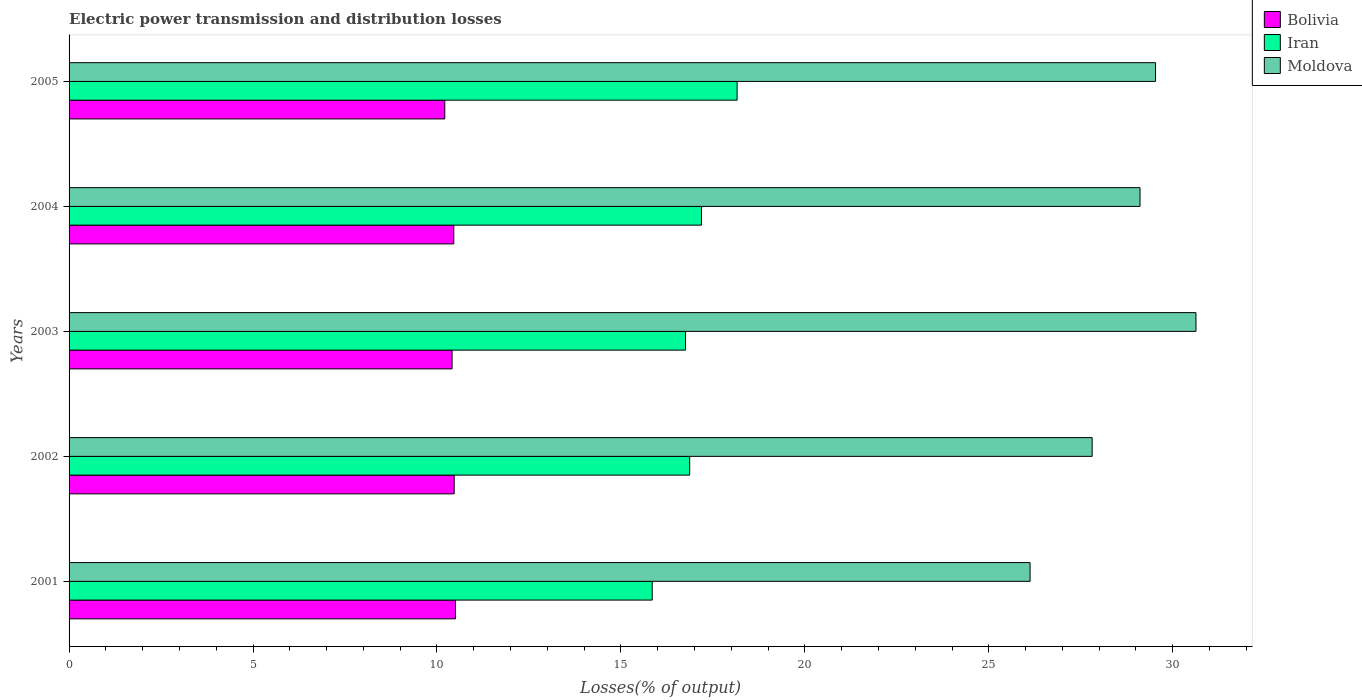How many different coloured bars are there?
Offer a very short reply. 3. Are the number of bars on each tick of the Y-axis equal?
Provide a short and direct response. Yes. How many bars are there on the 1st tick from the top?
Offer a terse response. 3. What is the electric power transmission and distribution losses in Iran in 2002?
Give a very brief answer. 16.87. Across all years, what is the maximum electric power transmission and distribution losses in Moldova?
Your response must be concise. 30.63. Across all years, what is the minimum electric power transmission and distribution losses in Bolivia?
Your answer should be very brief. 10.21. In which year was the electric power transmission and distribution losses in Iran maximum?
Offer a terse response. 2005. What is the total electric power transmission and distribution losses in Iran in the graph?
Provide a succinct answer. 84.82. What is the difference between the electric power transmission and distribution losses in Iran in 2001 and that in 2002?
Provide a succinct answer. -1.02. What is the difference between the electric power transmission and distribution losses in Moldova in 2005 and the electric power transmission and distribution losses in Bolivia in 2001?
Make the answer very short. 19.03. What is the average electric power transmission and distribution losses in Moldova per year?
Offer a terse response. 28.64. In the year 2005, what is the difference between the electric power transmission and distribution losses in Moldova and electric power transmission and distribution losses in Iran?
Make the answer very short. 11.37. What is the ratio of the electric power transmission and distribution losses in Iran in 2001 to that in 2004?
Give a very brief answer. 0.92. Is the electric power transmission and distribution losses in Iran in 2003 less than that in 2005?
Offer a terse response. Yes. What is the difference between the highest and the second highest electric power transmission and distribution losses in Iran?
Offer a terse response. 0.97. What is the difference between the highest and the lowest electric power transmission and distribution losses in Bolivia?
Provide a succinct answer. 0.29. In how many years, is the electric power transmission and distribution losses in Iran greater than the average electric power transmission and distribution losses in Iran taken over all years?
Your response must be concise. 2. What does the 1st bar from the top in 2003 represents?
Provide a short and direct response. Moldova. What does the 2nd bar from the bottom in 2001 represents?
Provide a short and direct response. Iran. Is it the case that in every year, the sum of the electric power transmission and distribution losses in Moldova and electric power transmission and distribution losses in Bolivia is greater than the electric power transmission and distribution losses in Iran?
Provide a succinct answer. Yes. How many bars are there?
Provide a succinct answer. 15. How many years are there in the graph?
Provide a succinct answer. 5. Are the values on the major ticks of X-axis written in scientific E-notation?
Your answer should be compact. No. How many legend labels are there?
Give a very brief answer. 3. What is the title of the graph?
Keep it short and to the point. Electric power transmission and distribution losses. Does "Guyana" appear as one of the legend labels in the graph?
Offer a very short reply. No. What is the label or title of the X-axis?
Give a very brief answer. Losses(% of output). What is the label or title of the Y-axis?
Keep it short and to the point. Years. What is the Losses(% of output) in Bolivia in 2001?
Provide a succinct answer. 10.5. What is the Losses(% of output) of Iran in 2001?
Make the answer very short. 15.85. What is the Losses(% of output) of Moldova in 2001?
Your response must be concise. 26.12. What is the Losses(% of output) of Bolivia in 2002?
Offer a terse response. 10.47. What is the Losses(% of output) of Iran in 2002?
Your answer should be compact. 16.87. What is the Losses(% of output) in Moldova in 2002?
Your answer should be very brief. 27.81. What is the Losses(% of output) of Bolivia in 2003?
Ensure brevity in your answer.  10.41. What is the Losses(% of output) in Iran in 2003?
Offer a terse response. 16.76. What is the Losses(% of output) of Moldova in 2003?
Your answer should be very brief. 30.63. What is the Losses(% of output) in Bolivia in 2004?
Offer a terse response. 10.46. What is the Losses(% of output) in Iran in 2004?
Your response must be concise. 17.19. What is the Losses(% of output) in Moldova in 2004?
Offer a very short reply. 29.11. What is the Losses(% of output) of Bolivia in 2005?
Make the answer very short. 10.21. What is the Losses(% of output) in Iran in 2005?
Offer a very short reply. 18.16. What is the Losses(% of output) in Moldova in 2005?
Your answer should be compact. 29.53. Across all years, what is the maximum Losses(% of output) in Bolivia?
Provide a short and direct response. 10.5. Across all years, what is the maximum Losses(% of output) of Iran?
Ensure brevity in your answer.  18.16. Across all years, what is the maximum Losses(% of output) of Moldova?
Your response must be concise. 30.63. Across all years, what is the minimum Losses(% of output) of Bolivia?
Your response must be concise. 10.21. Across all years, what is the minimum Losses(% of output) in Iran?
Provide a succinct answer. 15.85. Across all years, what is the minimum Losses(% of output) in Moldova?
Give a very brief answer. 26.12. What is the total Losses(% of output) in Bolivia in the graph?
Offer a very short reply. 52.05. What is the total Losses(% of output) in Iran in the graph?
Provide a short and direct response. 84.82. What is the total Losses(% of output) in Moldova in the graph?
Ensure brevity in your answer.  143.21. What is the difference between the Losses(% of output) of Bolivia in 2001 and that in 2002?
Provide a succinct answer. 0.03. What is the difference between the Losses(% of output) in Iran in 2001 and that in 2002?
Your answer should be very brief. -1.02. What is the difference between the Losses(% of output) of Moldova in 2001 and that in 2002?
Your response must be concise. -1.69. What is the difference between the Losses(% of output) in Bolivia in 2001 and that in 2003?
Give a very brief answer. 0.09. What is the difference between the Losses(% of output) in Iran in 2001 and that in 2003?
Your response must be concise. -0.91. What is the difference between the Losses(% of output) in Moldova in 2001 and that in 2003?
Provide a succinct answer. -4.51. What is the difference between the Losses(% of output) in Bolivia in 2001 and that in 2004?
Your answer should be compact. 0.04. What is the difference between the Losses(% of output) in Iran in 2001 and that in 2004?
Offer a terse response. -1.34. What is the difference between the Losses(% of output) in Moldova in 2001 and that in 2004?
Provide a short and direct response. -2.99. What is the difference between the Losses(% of output) of Bolivia in 2001 and that in 2005?
Your response must be concise. 0.29. What is the difference between the Losses(% of output) of Iran in 2001 and that in 2005?
Give a very brief answer. -2.31. What is the difference between the Losses(% of output) in Moldova in 2001 and that in 2005?
Your answer should be compact. -3.41. What is the difference between the Losses(% of output) of Bolivia in 2002 and that in 2003?
Give a very brief answer. 0.06. What is the difference between the Losses(% of output) of Iran in 2002 and that in 2003?
Keep it short and to the point. 0.11. What is the difference between the Losses(% of output) in Moldova in 2002 and that in 2003?
Offer a very short reply. -2.82. What is the difference between the Losses(% of output) of Bolivia in 2002 and that in 2004?
Provide a succinct answer. 0.01. What is the difference between the Losses(% of output) in Iran in 2002 and that in 2004?
Your answer should be very brief. -0.32. What is the difference between the Losses(% of output) of Moldova in 2002 and that in 2004?
Keep it short and to the point. -1.3. What is the difference between the Losses(% of output) in Bolivia in 2002 and that in 2005?
Ensure brevity in your answer.  0.26. What is the difference between the Losses(% of output) in Iran in 2002 and that in 2005?
Your answer should be very brief. -1.29. What is the difference between the Losses(% of output) in Moldova in 2002 and that in 2005?
Give a very brief answer. -1.72. What is the difference between the Losses(% of output) of Bolivia in 2003 and that in 2004?
Provide a succinct answer. -0.05. What is the difference between the Losses(% of output) of Iran in 2003 and that in 2004?
Keep it short and to the point. -0.43. What is the difference between the Losses(% of output) in Moldova in 2003 and that in 2004?
Your answer should be very brief. 1.52. What is the difference between the Losses(% of output) in Bolivia in 2003 and that in 2005?
Give a very brief answer. 0.2. What is the difference between the Losses(% of output) in Iran in 2003 and that in 2005?
Provide a short and direct response. -1.4. What is the difference between the Losses(% of output) of Moldova in 2003 and that in 2005?
Give a very brief answer. 1.1. What is the difference between the Losses(% of output) in Bolivia in 2004 and that in 2005?
Provide a succinct answer. 0.25. What is the difference between the Losses(% of output) in Iran in 2004 and that in 2005?
Keep it short and to the point. -0.97. What is the difference between the Losses(% of output) of Moldova in 2004 and that in 2005?
Provide a succinct answer. -0.42. What is the difference between the Losses(% of output) in Bolivia in 2001 and the Losses(% of output) in Iran in 2002?
Provide a succinct answer. -6.37. What is the difference between the Losses(% of output) in Bolivia in 2001 and the Losses(% of output) in Moldova in 2002?
Provide a succinct answer. -17.31. What is the difference between the Losses(% of output) in Iran in 2001 and the Losses(% of output) in Moldova in 2002?
Your response must be concise. -11.96. What is the difference between the Losses(% of output) in Bolivia in 2001 and the Losses(% of output) in Iran in 2003?
Offer a very short reply. -6.25. What is the difference between the Losses(% of output) in Bolivia in 2001 and the Losses(% of output) in Moldova in 2003?
Give a very brief answer. -20.13. What is the difference between the Losses(% of output) of Iran in 2001 and the Losses(% of output) of Moldova in 2003?
Offer a very short reply. -14.78. What is the difference between the Losses(% of output) in Bolivia in 2001 and the Losses(% of output) in Iran in 2004?
Offer a terse response. -6.69. What is the difference between the Losses(% of output) in Bolivia in 2001 and the Losses(% of output) in Moldova in 2004?
Make the answer very short. -18.61. What is the difference between the Losses(% of output) of Iran in 2001 and the Losses(% of output) of Moldova in 2004?
Keep it short and to the point. -13.26. What is the difference between the Losses(% of output) in Bolivia in 2001 and the Losses(% of output) in Iran in 2005?
Your answer should be compact. -7.66. What is the difference between the Losses(% of output) in Bolivia in 2001 and the Losses(% of output) in Moldova in 2005?
Ensure brevity in your answer.  -19.03. What is the difference between the Losses(% of output) of Iran in 2001 and the Losses(% of output) of Moldova in 2005?
Your answer should be very brief. -13.68. What is the difference between the Losses(% of output) of Bolivia in 2002 and the Losses(% of output) of Iran in 2003?
Provide a short and direct response. -6.29. What is the difference between the Losses(% of output) of Bolivia in 2002 and the Losses(% of output) of Moldova in 2003?
Your response must be concise. -20.16. What is the difference between the Losses(% of output) in Iran in 2002 and the Losses(% of output) in Moldova in 2003?
Ensure brevity in your answer.  -13.76. What is the difference between the Losses(% of output) in Bolivia in 2002 and the Losses(% of output) in Iran in 2004?
Offer a very short reply. -6.72. What is the difference between the Losses(% of output) of Bolivia in 2002 and the Losses(% of output) of Moldova in 2004?
Offer a terse response. -18.64. What is the difference between the Losses(% of output) of Iran in 2002 and the Losses(% of output) of Moldova in 2004?
Ensure brevity in your answer.  -12.24. What is the difference between the Losses(% of output) of Bolivia in 2002 and the Losses(% of output) of Iran in 2005?
Your answer should be very brief. -7.69. What is the difference between the Losses(% of output) of Bolivia in 2002 and the Losses(% of output) of Moldova in 2005?
Keep it short and to the point. -19.06. What is the difference between the Losses(% of output) of Iran in 2002 and the Losses(% of output) of Moldova in 2005?
Keep it short and to the point. -12.66. What is the difference between the Losses(% of output) in Bolivia in 2003 and the Losses(% of output) in Iran in 2004?
Provide a succinct answer. -6.78. What is the difference between the Losses(% of output) of Bolivia in 2003 and the Losses(% of output) of Moldova in 2004?
Your response must be concise. -18.7. What is the difference between the Losses(% of output) in Iran in 2003 and the Losses(% of output) in Moldova in 2004?
Give a very brief answer. -12.35. What is the difference between the Losses(% of output) in Bolivia in 2003 and the Losses(% of output) in Iran in 2005?
Your response must be concise. -7.75. What is the difference between the Losses(% of output) of Bolivia in 2003 and the Losses(% of output) of Moldova in 2005?
Provide a succinct answer. -19.12. What is the difference between the Losses(% of output) in Iran in 2003 and the Losses(% of output) in Moldova in 2005?
Your answer should be compact. -12.78. What is the difference between the Losses(% of output) in Bolivia in 2004 and the Losses(% of output) in Iran in 2005?
Provide a short and direct response. -7.7. What is the difference between the Losses(% of output) in Bolivia in 2004 and the Losses(% of output) in Moldova in 2005?
Give a very brief answer. -19.07. What is the difference between the Losses(% of output) in Iran in 2004 and the Losses(% of output) in Moldova in 2005?
Give a very brief answer. -12.34. What is the average Losses(% of output) of Bolivia per year?
Give a very brief answer. 10.41. What is the average Losses(% of output) in Iran per year?
Keep it short and to the point. 16.96. What is the average Losses(% of output) in Moldova per year?
Make the answer very short. 28.64. In the year 2001, what is the difference between the Losses(% of output) of Bolivia and Losses(% of output) of Iran?
Provide a succinct answer. -5.35. In the year 2001, what is the difference between the Losses(% of output) in Bolivia and Losses(% of output) in Moldova?
Your response must be concise. -15.62. In the year 2001, what is the difference between the Losses(% of output) in Iran and Losses(% of output) in Moldova?
Offer a very short reply. -10.27. In the year 2002, what is the difference between the Losses(% of output) in Bolivia and Losses(% of output) in Iran?
Offer a very short reply. -6.4. In the year 2002, what is the difference between the Losses(% of output) in Bolivia and Losses(% of output) in Moldova?
Keep it short and to the point. -17.34. In the year 2002, what is the difference between the Losses(% of output) of Iran and Losses(% of output) of Moldova?
Give a very brief answer. -10.94. In the year 2003, what is the difference between the Losses(% of output) of Bolivia and Losses(% of output) of Iran?
Provide a short and direct response. -6.35. In the year 2003, what is the difference between the Losses(% of output) in Bolivia and Losses(% of output) in Moldova?
Your answer should be very brief. -20.22. In the year 2003, what is the difference between the Losses(% of output) in Iran and Losses(% of output) in Moldova?
Keep it short and to the point. -13.87. In the year 2004, what is the difference between the Losses(% of output) in Bolivia and Losses(% of output) in Iran?
Provide a short and direct response. -6.73. In the year 2004, what is the difference between the Losses(% of output) in Bolivia and Losses(% of output) in Moldova?
Make the answer very short. -18.65. In the year 2004, what is the difference between the Losses(% of output) in Iran and Losses(% of output) in Moldova?
Keep it short and to the point. -11.92. In the year 2005, what is the difference between the Losses(% of output) of Bolivia and Losses(% of output) of Iran?
Your response must be concise. -7.95. In the year 2005, what is the difference between the Losses(% of output) in Bolivia and Losses(% of output) in Moldova?
Give a very brief answer. -19.32. In the year 2005, what is the difference between the Losses(% of output) in Iran and Losses(% of output) in Moldova?
Provide a succinct answer. -11.37. What is the ratio of the Losses(% of output) in Bolivia in 2001 to that in 2002?
Give a very brief answer. 1. What is the ratio of the Losses(% of output) of Iran in 2001 to that in 2002?
Your response must be concise. 0.94. What is the ratio of the Losses(% of output) in Moldova in 2001 to that in 2002?
Your answer should be compact. 0.94. What is the ratio of the Losses(% of output) in Bolivia in 2001 to that in 2003?
Make the answer very short. 1.01. What is the ratio of the Losses(% of output) of Iran in 2001 to that in 2003?
Provide a short and direct response. 0.95. What is the ratio of the Losses(% of output) of Moldova in 2001 to that in 2003?
Provide a short and direct response. 0.85. What is the ratio of the Losses(% of output) of Iran in 2001 to that in 2004?
Keep it short and to the point. 0.92. What is the ratio of the Losses(% of output) in Moldova in 2001 to that in 2004?
Ensure brevity in your answer.  0.9. What is the ratio of the Losses(% of output) in Bolivia in 2001 to that in 2005?
Provide a succinct answer. 1.03. What is the ratio of the Losses(% of output) in Iran in 2001 to that in 2005?
Make the answer very short. 0.87. What is the ratio of the Losses(% of output) in Moldova in 2001 to that in 2005?
Offer a terse response. 0.88. What is the ratio of the Losses(% of output) of Moldova in 2002 to that in 2003?
Offer a terse response. 0.91. What is the ratio of the Losses(% of output) of Iran in 2002 to that in 2004?
Provide a short and direct response. 0.98. What is the ratio of the Losses(% of output) in Moldova in 2002 to that in 2004?
Your answer should be very brief. 0.96. What is the ratio of the Losses(% of output) of Bolivia in 2002 to that in 2005?
Make the answer very short. 1.03. What is the ratio of the Losses(% of output) of Iran in 2002 to that in 2005?
Provide a succinct answer. 0.93. What is the ratio of the Losses(% of output) in Moldova in 2002 to that in 2005?
Your response must be concise. 0.94. What is the ratio of the Losses(% of output) of Iran in 2003 to that in 2004?
Keep it short and to the point. 0.97. What is the ratio of the Losses(% of output) of Moldova in 2003 to that in 2004?
Offer a very short reply. 1.05. What is the ratio of the Losses(% of output) in Bolivia in 2003 to that in 2005?
Ensure brevity in your answer.  1.02. What is the ratio of the Losses(% of output) in Iran in 2003 to that in 2005?
Keep it short and to the point. 0.92. What is the ratio of the Losses(% of output) of Moldova in 2003 to that in 2005?
Provide a short and direct response. 1.04. What is the ratio of the Losses(% of output) in Bolivia in 2004 to that in 2005?
Offer a very short reply. 1.02. What is the ratio of the Losses(% of output) of Iran in 2004 to that in 2005?
Offer a terse response. 0.95. What is the ratio of the Losses(% of output) in Moldova in 2004 to that in 2005?
Make the answer very short. 0.99. What is the difference between the highest and the second highest Losses(% of output) in Bolivia?
Keep it short and to the point. 0.03. What is the difference between the highest and the second highest Losses(% of output) of Iran?
Offer a very short reply. 0.97. What is the difference between the highest and the second highest Losses(% of output) in Moldova?
Offer a very short reply. 1.1. What is the difference between the highest and the lowest Losses(% of output) in Bolivia?
Your answer should be compact. 0.29. What is the difference between the highest and the lowest Losses(% of output) of Iran?
Keep it short and to the point. 2.31. What is the difference between the highest and the lowest Losses(% of output) of Moldova?
Offer a very short reply. 4.51. 